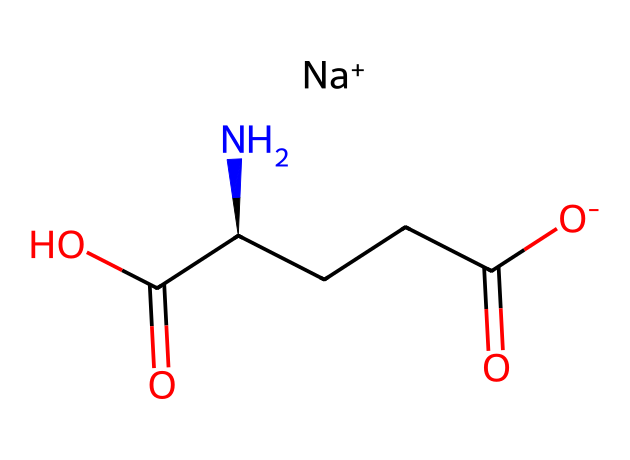How many carbon atoms are present in monosodium glutamate? By analyzing the structure provided in the SMILES representation, we identify the carbon atoms represented by "C" and the carbon backbone connecting the functional groups. There are five 'C' notations in the SMILES string.
Answer: five What is the role of sodium in this chemical? The sodium (Na+) ion is a counterion that balances the negative charge of the carboxylate group (-O) in the structure. This helps stabilize the overall structure of monosodium glutamate.
Answer: flavor enhancer Which functional groups are present in monosodium glutamate? The SMILES representation indicates the presence of carboxylic acid groups (-COOH), and an amino group (-NH2) attached to a carbon chain.
Answer: carboxylic acid, amino What is the total number of hydrogen atoms in monosodium glutamate? By analyzing the hydrogen atom bonding in the structure, we account for the hydrogen atoms attached to the carbon, nitrogen, and those associated with the carboxylic acid groups. There are a total of 8 hydrogen atoms.
Answer: eight What type of compound is monosodium glutamate classified as? Monosodium glutamate is classified as an amino acid derivative due to the presence of both an amino group (-NH2) and a carboxylic acid group (-COOH) within its structure.
Answer: amino acid derivative What effect does the sodium ion have on the taste of monosodium glutamate? The sodium ion in MSG enhances the umami flavor, which is a savory taste profile, making individual food items more flavorful. This is a crucial aspect of why MSG is widely used in culinary applications.
Answer: enhances umami flavor 